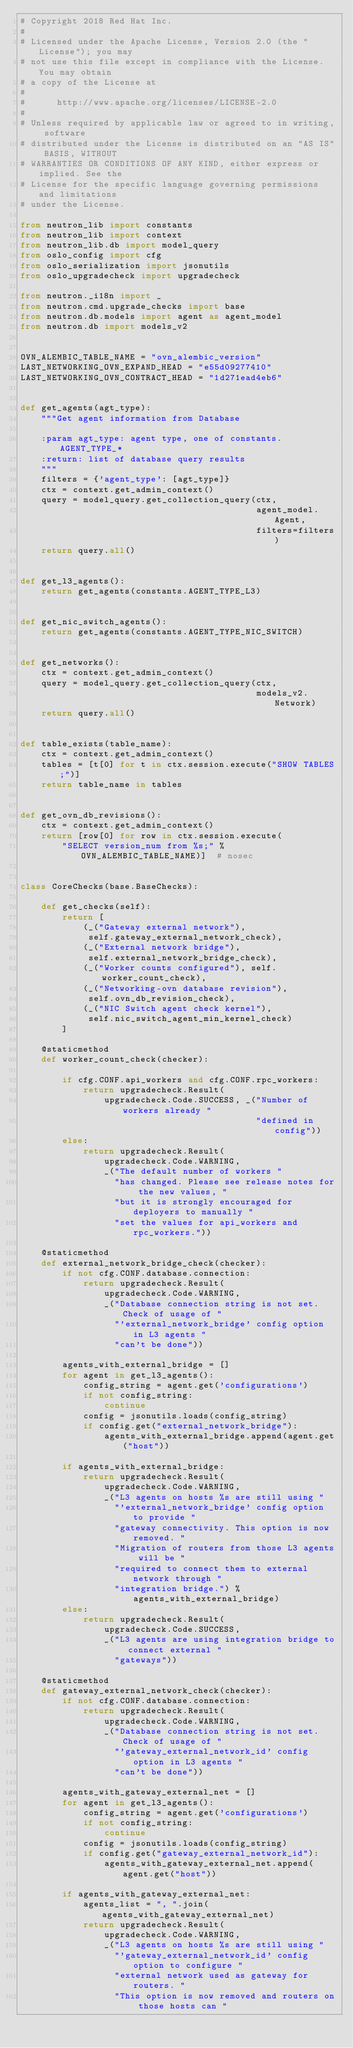<code> <loc_0><loc_0><loc_500><loc_500><_Python_># Copyright 2018 Red Hat Inc.
#
# Licensed under the Apache License, Version 2.0 (the "License"); you may
# not use this file except in compliance with the License. You may obtain
# a copy of the License at
#
#      http://www.apache.org/licenses/LICENSE-2.0
#
# Unless required by applicable law or agreed to in writing, software
# distributed under the License is distributed on an "AS IS" BASIS, WITHOUT
# WARRANTIES OR CONDITIONS OF ANY KIND, either express or implied. See the
# License for the specific language governing permissions and limitations
# under the License.

from neutron_lib import constants
from neutron_lib import context
from neutron_lib.db import model_query
from oslo_config import cfg
from oslo_serialization import jsonutils
from oslo_upgradecheck import upgradecheck

from neutron._i18n import _
from neutron.cmd.upgrade_checks import base
from neutron.db.models import agent as agent_model
from neutron.db import models_v2


OVN_ALEMBIC_TABLE_NAME = "ovn_alembic_version"
LAST_NETWORKING_OVN_EXPAND_HEAD = "e55d09277410"
LAST_NETWORKING_OVN_CONTRACT_HEAD = "1d271ead4eb6"


def get_agents(agt_type):
    """Get agent information from Database

    :param agt_type: agent type, one of constants.AGENT_TYPE_*
    :return: list of database query results
    """
    filters = {'agent_type': [agt_type]}
    ctx = context.get_admin_context()
    query = model_query.get_collection_query(ctx,
                                             agent_model.Agent,
                                             filters=filters)
    return query.all()


def get_l3_agents():
    return get_agents(constants.AGENT_TYPE_L3)


def get_nic_switch_agents():
    return get_agents(constants.AGENT_TYPE_NIC_SWITCH)


def get_networks():
    ctx = context.get_admin_context()
    query = model_query.get_collection_query(ctx,
                                             models_v2.Network)
    return query.all()


def table_exists(table_name):
    ctx = context.get_admin_context()
    tables = [t[0] for t in ctx.session.execute("SHOW TABLES;")]
    return table_name in tables


def get_ovn_db_revisions():
    ctx = context.get_admin_context()
    return [row[0] for row in ctx.session.execute(
        "SELECT version_num from %s;" % OVN_ALEMBIC_TABLE_NAME)]  # nosec


class CoreChecks(base.BaseChecks):

    def get_checks(self):
        return [
            (_("Gateway external network"),
             self.gateway_external_network_check),
            (_("External network bridge"),
             self.external_network_bridge_check),
            (_("Worker counts configured"), self.worker_count_check),
            (_("Networking-ovn database revision"),
             self.ovn_db_revision_check),
            (_("NIC Switch agent check kernel"),
             self.nic_switch_agent_min_kernel_check)
        ]

    @staticmethod
    def worker_count_check(checker):

        if cfg.CONF.api_workers and cfg.CONF.rpc_workers:
            return upgradecheck.Result(
                upgradecheck.Code.SUCCESS, _("Number of workers already "
                                             "defined in config"))
        else:
            return upgradecheck.Result(
                upgradecheck.Code.WARNING,
                _("The default number of workers "
                  "has changed. Please see release notes for the new values, "
                  "but it is strongly encouraged for deployers to manually "
                  "set the values for api_workers and rpc_workers."))

    @staticmethod
    def external_network_bridge_check(checker):
        if not cfg.CONF.database.connection:
            return upgradecheck.Result(
                upgradecheck.Code.WARNING,
                _("Database connection string is not set. Check of usage of "
                  "'external_network_bridge' config option in L3 agents "
                  "can't be done"))

        agents_with_external_bridge = []
        for agent in get_l3_agents():
            config_string = agent.get('configurations')
            if not config_string:
                continue
            config = jsonutils.loads(config_string)
            if config.get("external_network_bridge"):
                agents_with_external_bridge.append(agent.get("host"))

        if agents_with_external_bridge:
            return upgradecheck.Result(
                upgradecheck.Code.WARNING,
                _("L3 agents on hosts %s are still using "
                  "'external_network_bridge' config option to provide "
                  "gateway connectivity. This option is now removed. "
                  "Migration of routers from those L3 agents will be "
                  "required to connect them to external network through "
                  "integration bridge.") % agents_with_external_bridge)
        else:
            return upgradecheck.Result(
                upgradecheck.Code.SUCCESS,
                _("L3 agents are using integration bridge to connect external "
                  "gateways"))

    @staticmethod
    def gateway_external_network_check(checker):
        if not cfg.CONF.database.connection:
            return upgradecheck.Result(
                upgradecheck.Code.WARNING,
                _("Database connection string is not set. Check of usage of "
                  "'gateway_external_network_id' config option in L3 agents "
                  "can't be done"))

        agents_with_gateway_external_net = []
        for agent in get_l3_agents():
            config_string = agent.get('configurations')
            if not config_string:
                continue
            config = jsonutils.loads(config_string)
            if config.get("gateway_external_network_id"):
                agents_with_gateway_external_net.append(agent.get("host"))

        if agents_with_gateway_external_net:
            agents_list = ", ".join(agents_with_gateway_external_net)
            return upgradecheck.Result(
                upgradecheck.Code.WARNING,
                _("L3 agents on hosts %s are still using "
                  "'gateway_external_network_id' config option to configure "
                  "external network used as gateway for routers. "
                  "This option is now removed and routers on those hosts can "</code> 